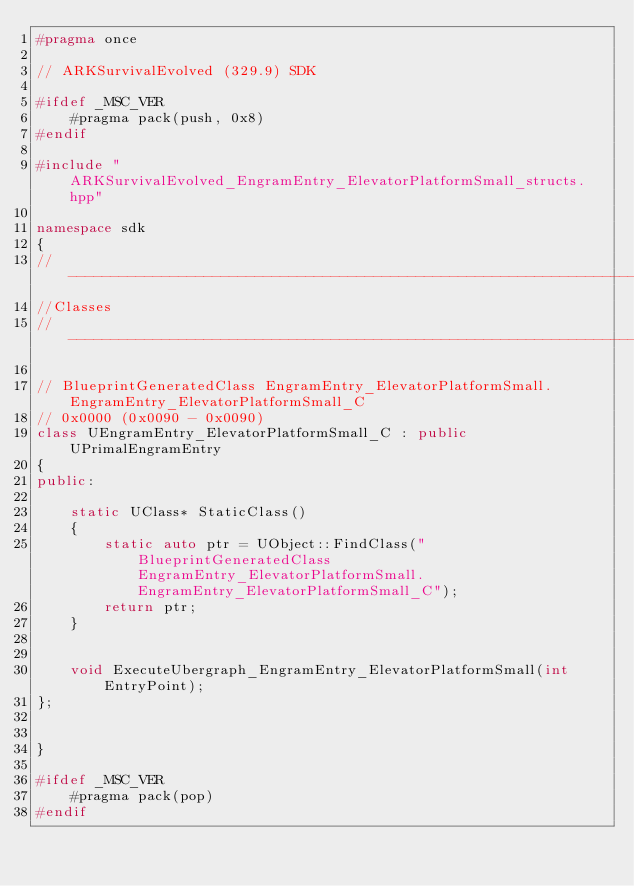Convert code to text. <code><loc_0><loc_0><loc_500><loc_500><_C++_>#pragma once

// ARKSurvivalEvolved (329.9) SDK

#ifdef _MSC_VER
	#pragma pack(push, 0x8)
#endif

#include "ARKSurvivalEvolved_EngramEntry_ElevatorPlatformSmall_structs.hpp"

namespace sdk
{
//---------------------------------------------------------------------------
//Classes
//---------------------------------------------------------------------------

// BlueprintGeneratedClass EngramEntry_ElevatorPlatformSmall.EngramEntry_ElevatorPlatformSmall_C
// 0x0000 (0x0090 - 0x0090)
class UEngramEntry_ElevatorPlatformSmall_C : public UPrimalEngramEntry
{
public:

	static UClass* StaticClass()
	{
		static auto ptr = UObject::FindClass("BlueprintGeneratedClass EngramEntry_ElevatorPlatformSmall.EngramEntry_ElevatorPlatformSmall_C");
		return ptr;
	}


	void ExecuteUbergraph_EngramEntry_ElevatorPlatformSmall(int EntryPoint);
};


}

#ifdef _MSC_VER
	#pragma pack(pop)
#endif
</code> 